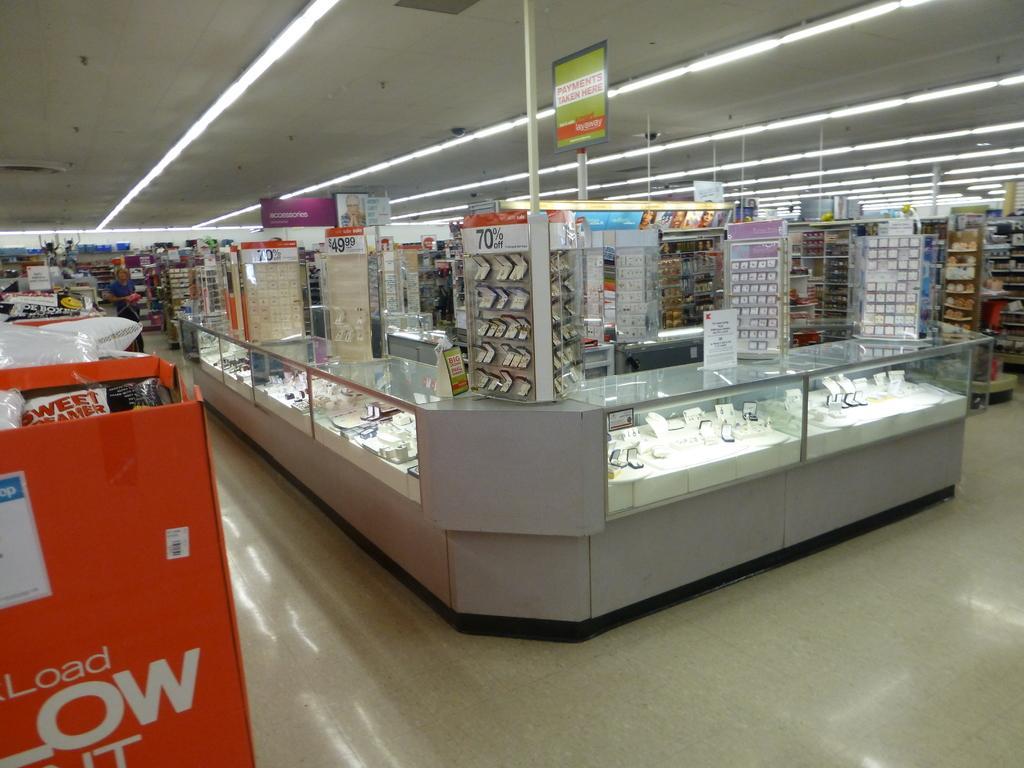Please provide a concise description of this image. In this image, I can see the objects, which are kept in the racks and display cabinets. At the top of the image, I can see the tube lights attached to the ceiling. At the bottom of the image, I can see the floor. 